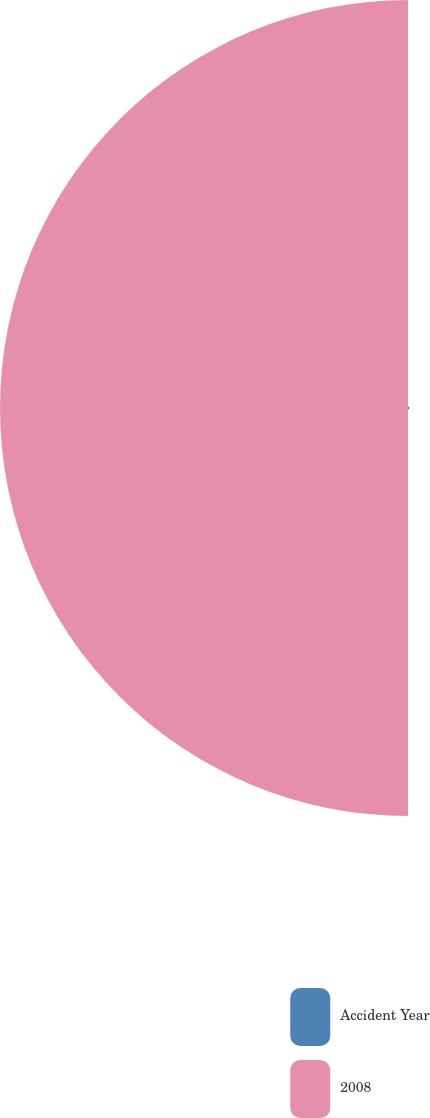<chart> <loc_0><loc_0><loc_500><loc_500><pie_chart><fcel>Accident Year<fcel>2008<nl><fcel>0.38%<fcel>99.62%<nl></chart> 